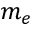Convert formula to latex. <formula><loc_0><loc_0><loc_500><loc_500>m _ { e }</formula> 